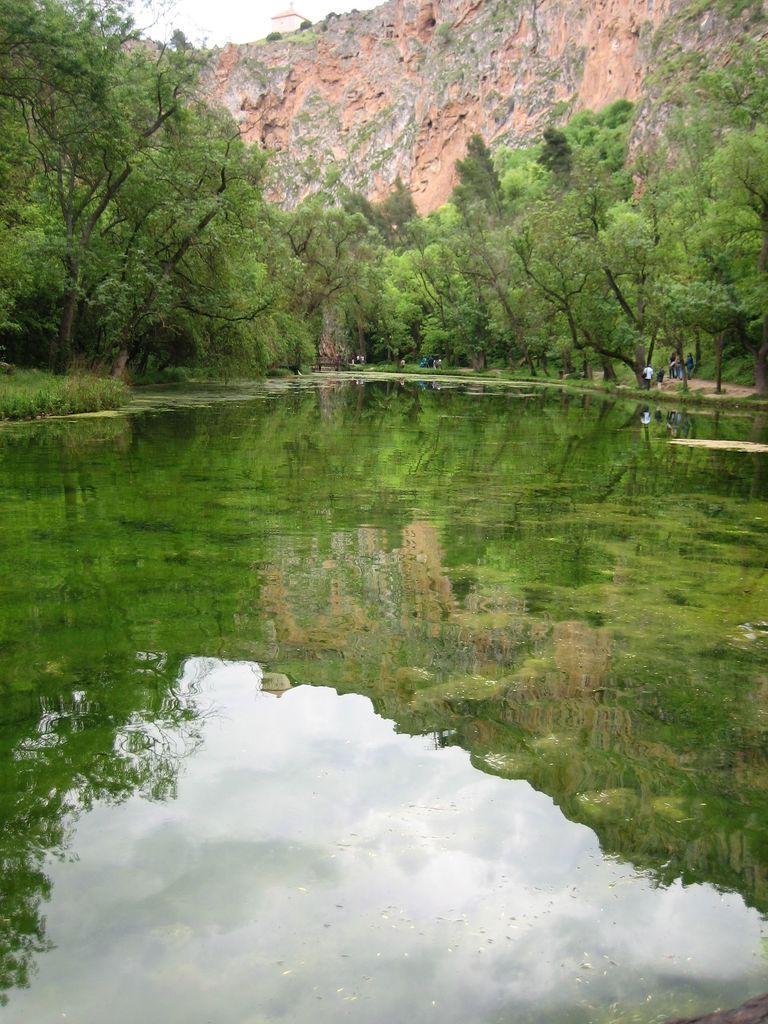Please provide a concise description of this image. This image consists of a water. In the front, we can see many trees. In the background, there is a mountain. At the top, there is sky. 